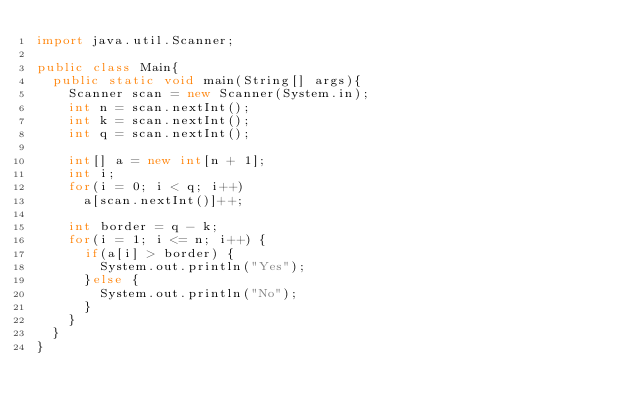Convert code to text. <code><loc_0><loc_0><loc_500><loc_500><_Java_>import java.util.Scanner;

public class Main{
	public static void main(String[] args){
		Scanner scan = new Scanner(System.in);
		int n = scan.nextInt();
		int k = scan.nextInt();
		int q = scan.nextInt();

		int[] a = new int[n + 1];
		int i;
		for(i = 0; i < q; i++)
			a[scan.nextInt()]++;

		int border = q - k;
		for(i = 1; i <= n; i++) {
			if(a[i] > border) {
				System.out.println("Yes");
			}else {
				System.out.println("No");
			}
		}
	}
}
</code> 